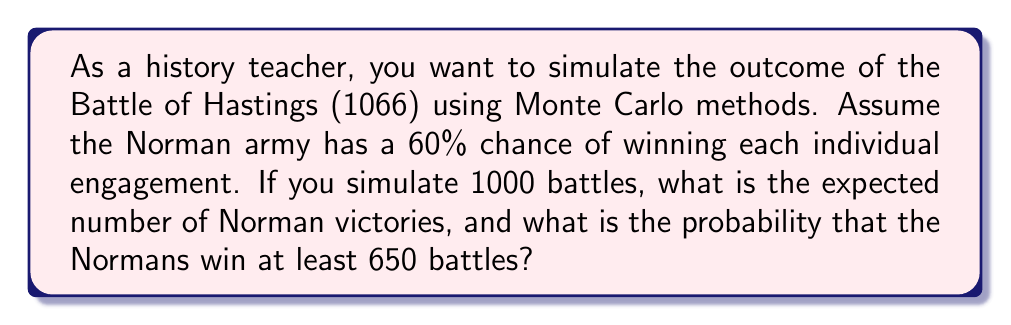Could you help me with this problem? Let's approach this step-by-step:

1) Expected number of Norman victories:
   - Each battle is a Bernoulli trial with p = 0.6 (60% chance of Norman victory)
   - We're simulating 1000 battles, so this follows a Binomial distribution
   - The expected value of a Binomial distribution is $n * p$
   - $E(X) = 1000 * 0.6 = 600$

2) Probability of Normans winning at least 650 battles:
   - We need to find $P(X \geq 650)$ where $X \sim Bin(1000, 0.6)$
   - This is equivalent to $1 - P(X < 650)$
   - We can use the normal approximation to the binomial distribution
   - For a binomial distribution: 
     $\mu = np = 1000 * 0.6 = 600$
     $\sigma = \sqrt{np(1-p)} = \sqrt{1000 * 0.6 * 0.4} = 15.49$
   - Standardizing: $z = \frac{649.5 - 600}{15.49} = 3.19$
     (We use 649.5 for continuity correction)
   - Using a standard normal table or calculator:
     $P(Z < 3.19) \approx 0.9993$
   - Therefore, $P(X \geq 650) = 1 - 0.9993 = 0.0007$
Answer: 600 expected Norman victories; 0.0007 probability of at least 650 Norman victories 